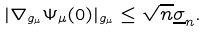<formula> <loc_0><loc_0><loc_500><loc_500>| \nabla _ { g _ { \mu } } \Psi _ { \mu } ( 0 ) | _ { g _ { \mu } } \leq \sqrt { n } \underline { \sigma } _ { n } .</formula> 